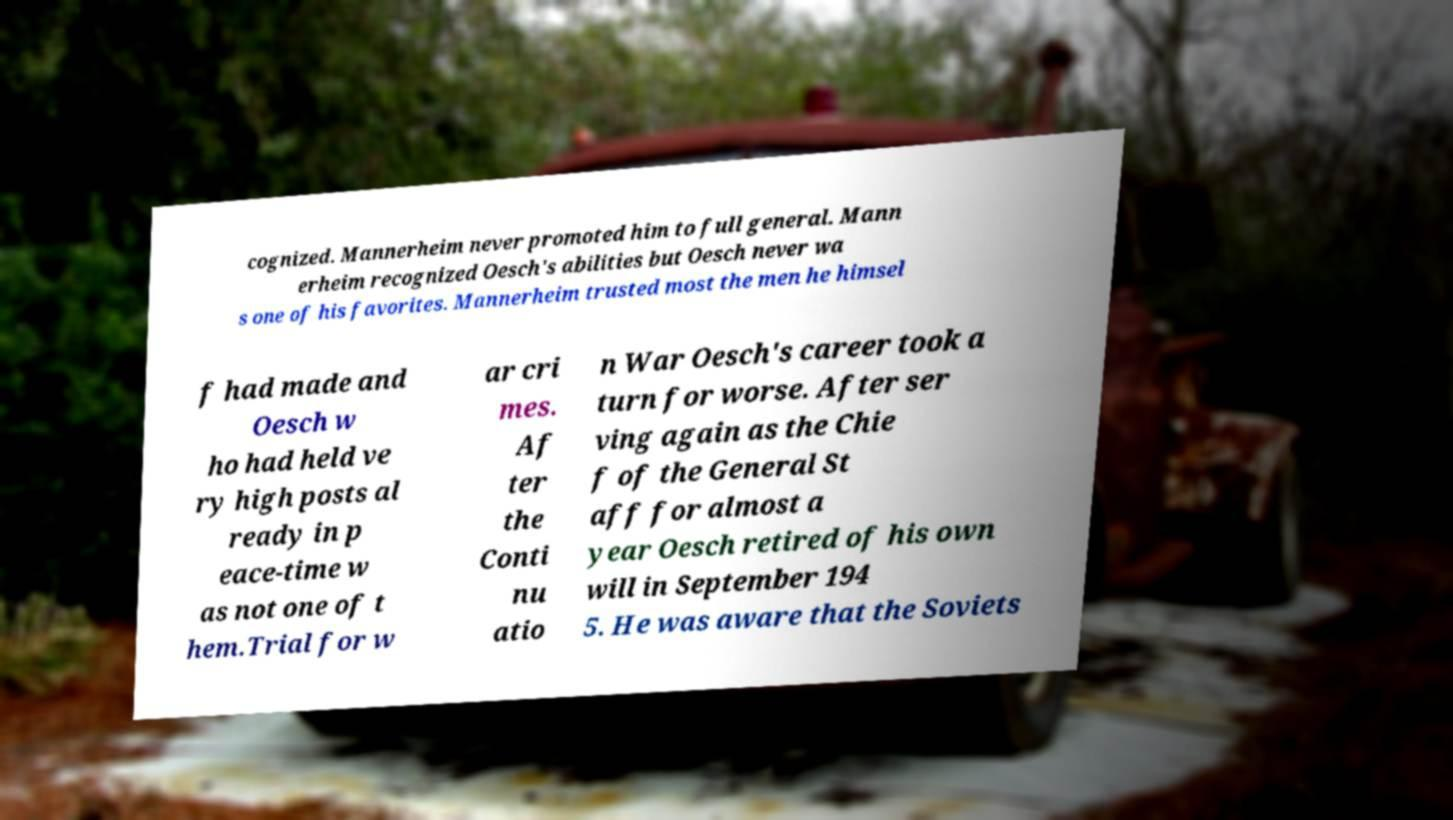Could you extract and type out the text from this image? cognized. Mannerheim never promoted him to full general. Mann erheim recognized Oesch's abilities but Oesch never wa s one of his favorites. Mannerheim trusted most the men he himsel f had made and Oesch w ho had held ve ry high posts al ready in p eace-time w as not one of t hem.Trial for w ar cri mes. Af ter the Conti nu atio n War Oesch's career took a turn for worse. After ser ving again as the Chie f of the General St aff for almost a year Oesch retired of his own will in September 194 5. He was aware that the Soviets 